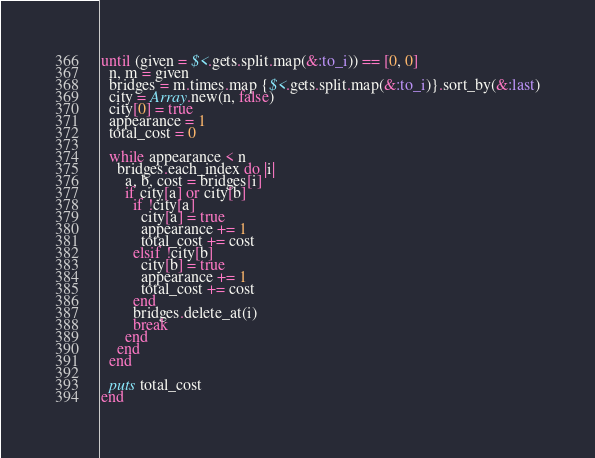<code> <loc_0><loc_0><loc_500><loc_500><_Ruby_>until (given = $<.gets.split.map(&:to_i)) == [0, 0]
  n, m = given
  bridges = m.times.map {$<.gets.split.map(&:to_i)}.sort_by(&:last)
  city = Array.new(n, false)
  city[0] = true
  appearance = 1
  total_cost = 0
  
  while appearance < n
    bridges.each_index do |i|
      a, b, cost = bridges[i]
      if city[a] or city[b]
        if !city[a]
          city[a] = true
          appearance += 1
          total_cost += cost
        elsif !city[b]
          city[b] = true
          appearance += 1
          total_cost += cost
        end
        bridges.delete_at(i)
        break
      end
    end
  end
  
  puts total_cost
end
</code> 